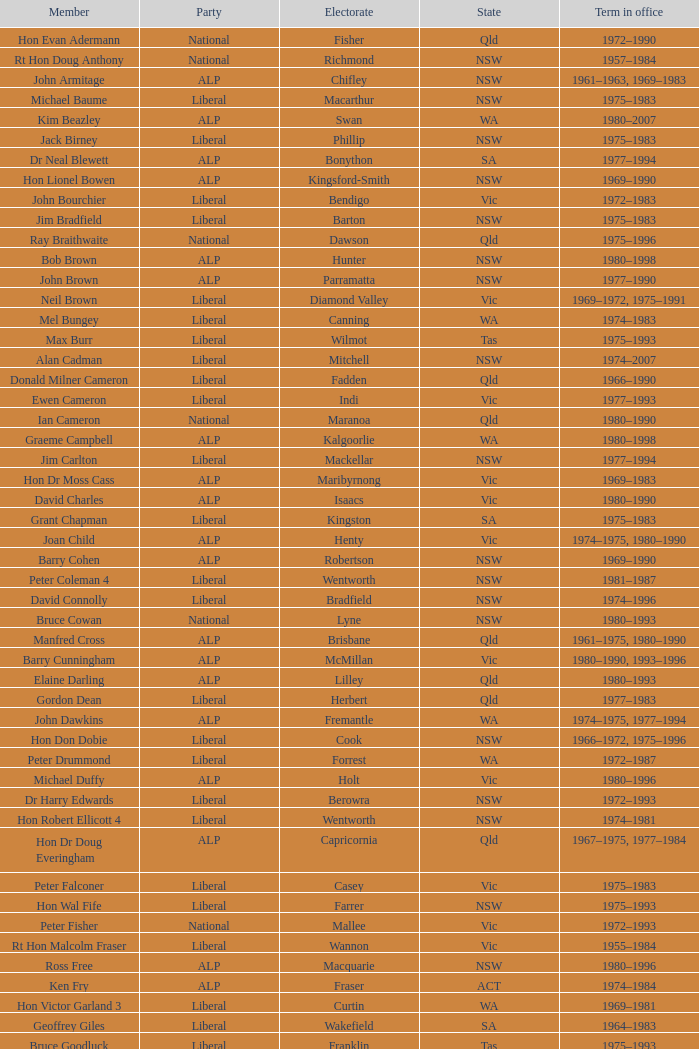What is ralph jacobi's political affiliation? ALP. 